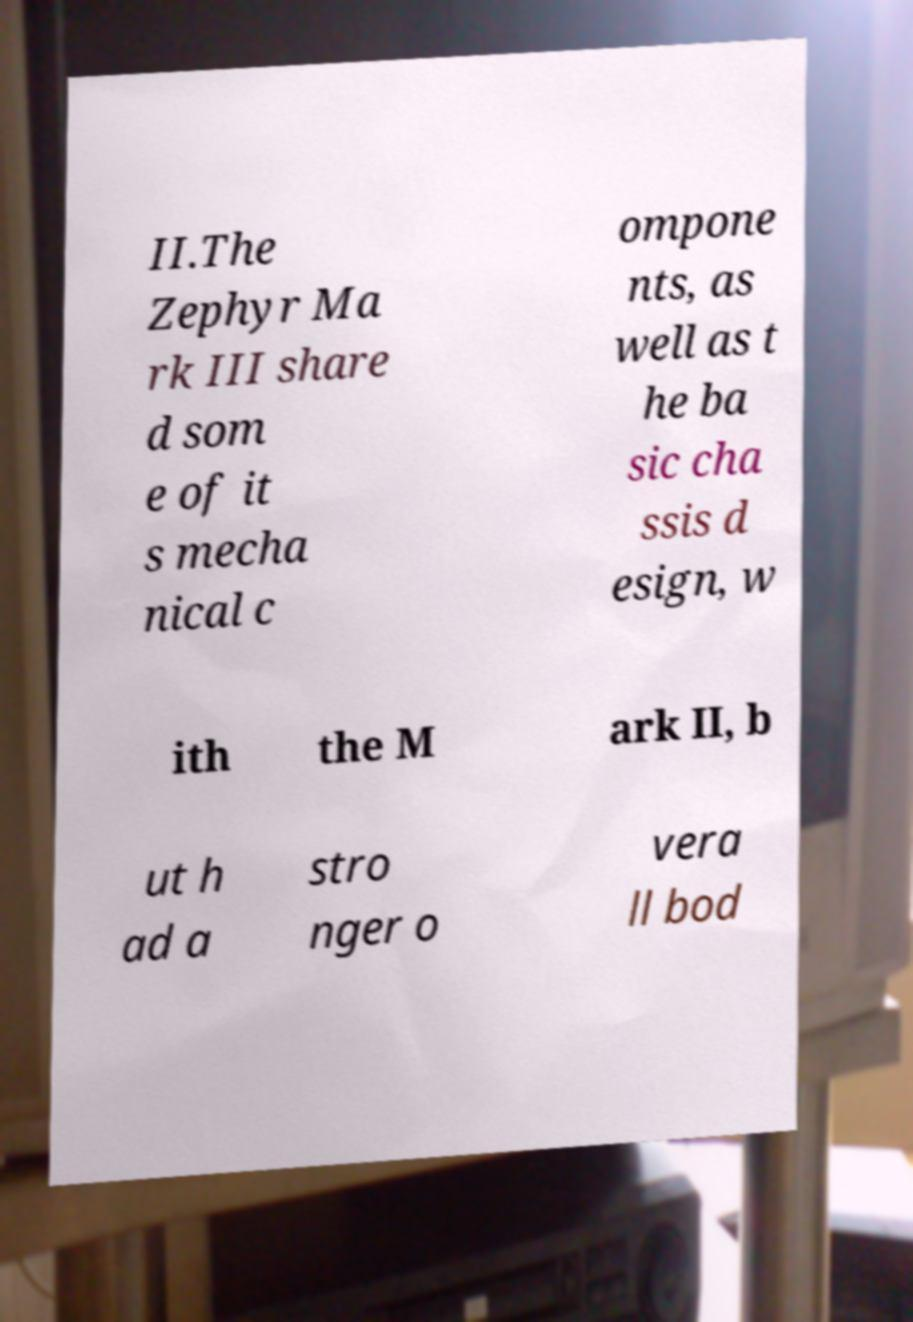I need the written content from this picture converted into text. Can you do that? II.The Zephyr Ma rk III share d som e of it s mecha nical c ompone nts, as well as t he ba sic cha ssis d esign, w ith the M ark II, b ut h ad a stro nger o vera ll bod 